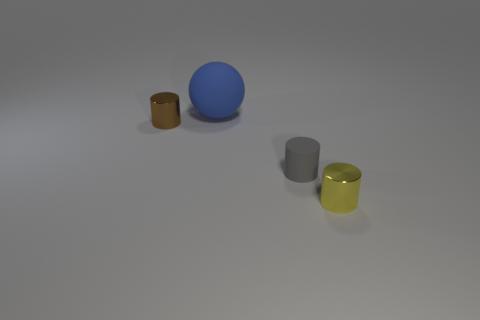Subtract all tiny yellow metal cylinders. How many cylinders are left? 2 Add 1 tiny yellow metal cylinders. How many objects exist? 5 Subtract 1 cylinders. How many cylinders are left? 2 Subtract all cylinders. How many objects are left? 1 Subtract all cyan cylinders. Subtract all purple balls. How many cylinders are left? 3 Subtract all gray metallic balls. Subtract all big matte objects. How many objects are left? 3 Add 4 blue matte spheres. How many blue matte spheres are left? 5 Add 3 big blue matte things. How many big blue matte things exist? 4 Subtract 0 purple balls. How many objects are left? 4 